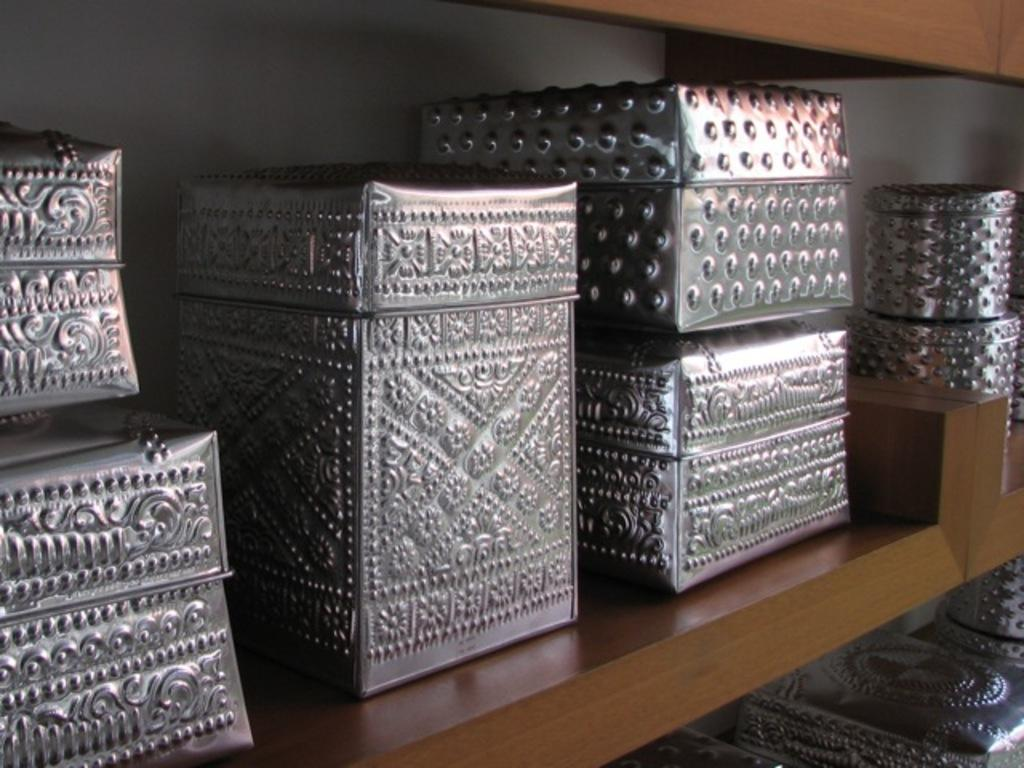What is located at the bottom of the image? There is a table at the bottom of the image. What is on top of the table? There are boxes on the table. What can be seen behind the table and boxes? There is a wall visible behind the table and boxes. What type of grip can be seen on the boxes in the image? There is no specific grip visible on the boxes in the image; they appear to be plain cardboard boxes. 